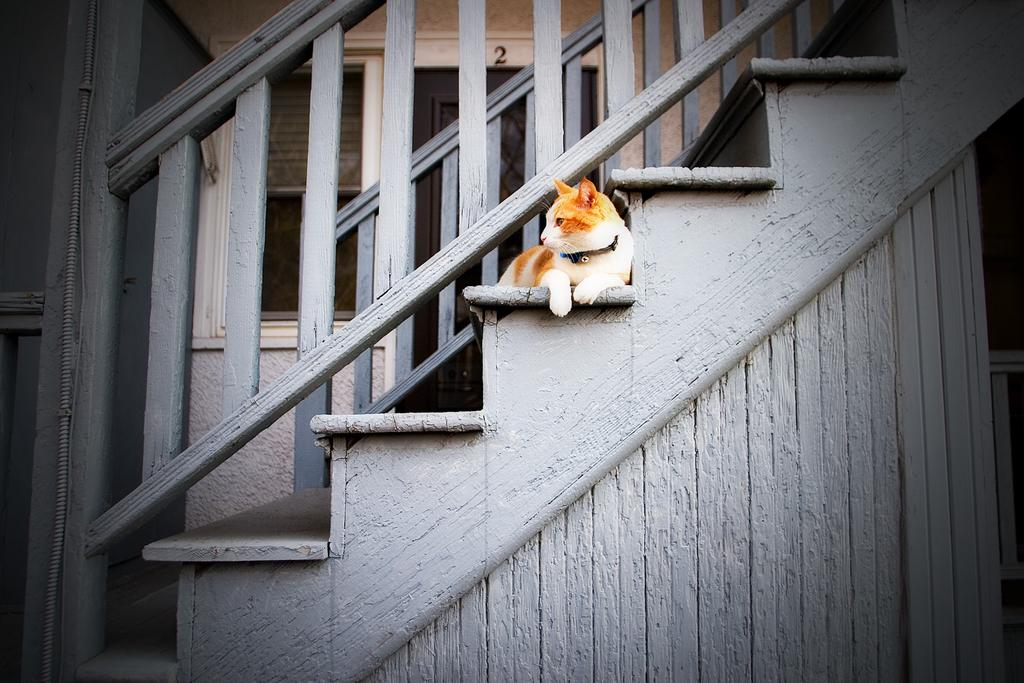What animal is in the foreground of the image? There is a cat in the foreground of the image. Where is the cat located? The cat is on wooden stairs. What is at the top of the stairs? There is a wooden railing at the top of the stairs. What can be seen in the background of the image? There is a window and a wall in the background of the image. What type of iron is being used by the cat in the image? There is no iron present in the image; it features a cat on wooden stairs. What act is the cat performing in the image? The image does not depict the cat performing any specific act; it simply shows the cat on the stairs. 